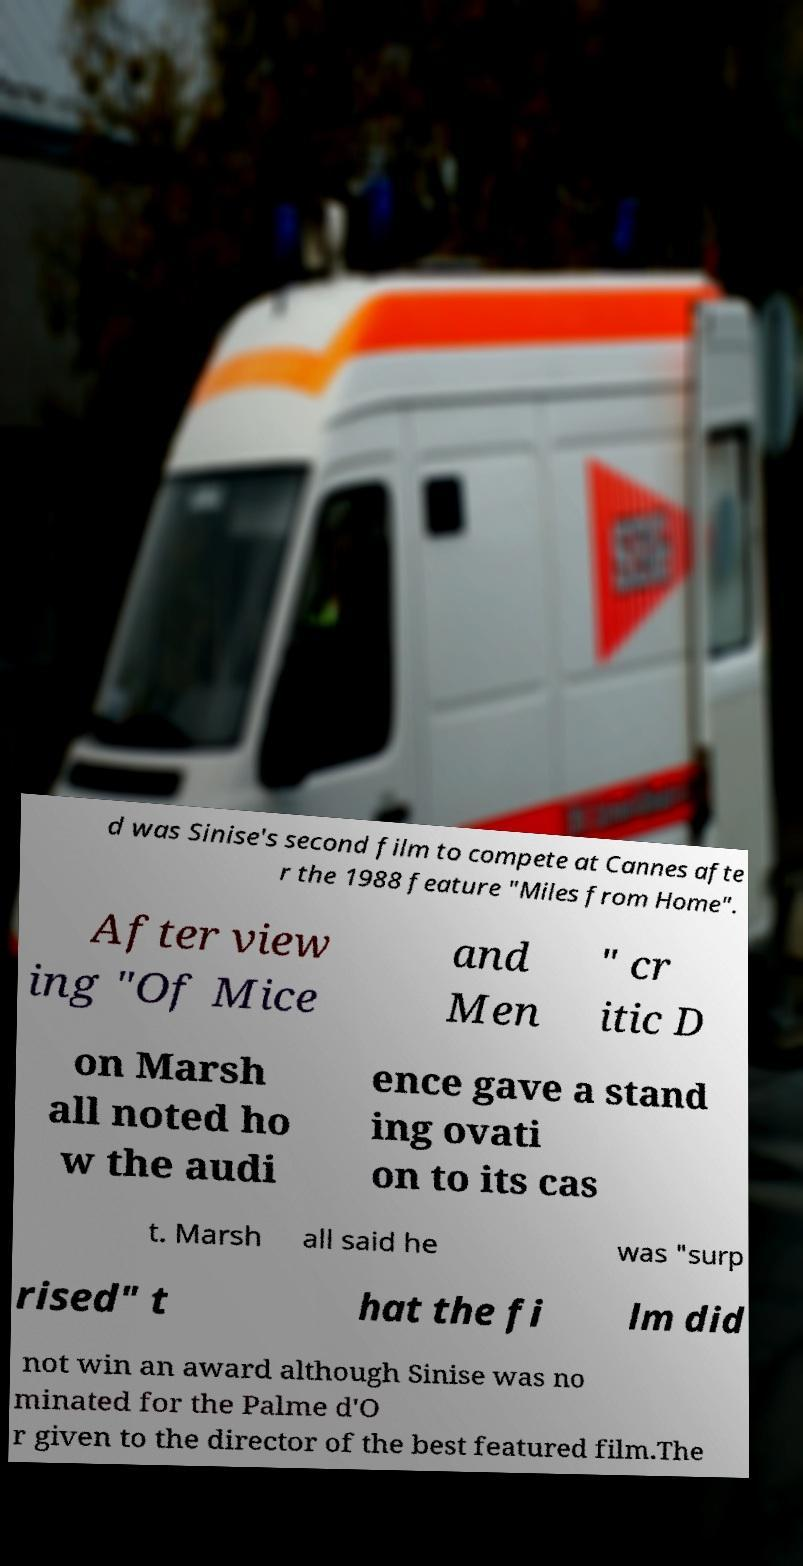Could you extract and type out the text from this image? d was Sinise's second film to compete at Cannes afte r the 1988 feature "Miles from Home". After view ing "Of Mice and Men " cr itic D on Marsh all noted ho w the audi ence gave a stand ing ovati on to its cas t. Marsh all said he was "surp rised" t hat the fi lm did not win an award although Sinise was no minated for the Palme d'O r given to the director of the best featured film.The 